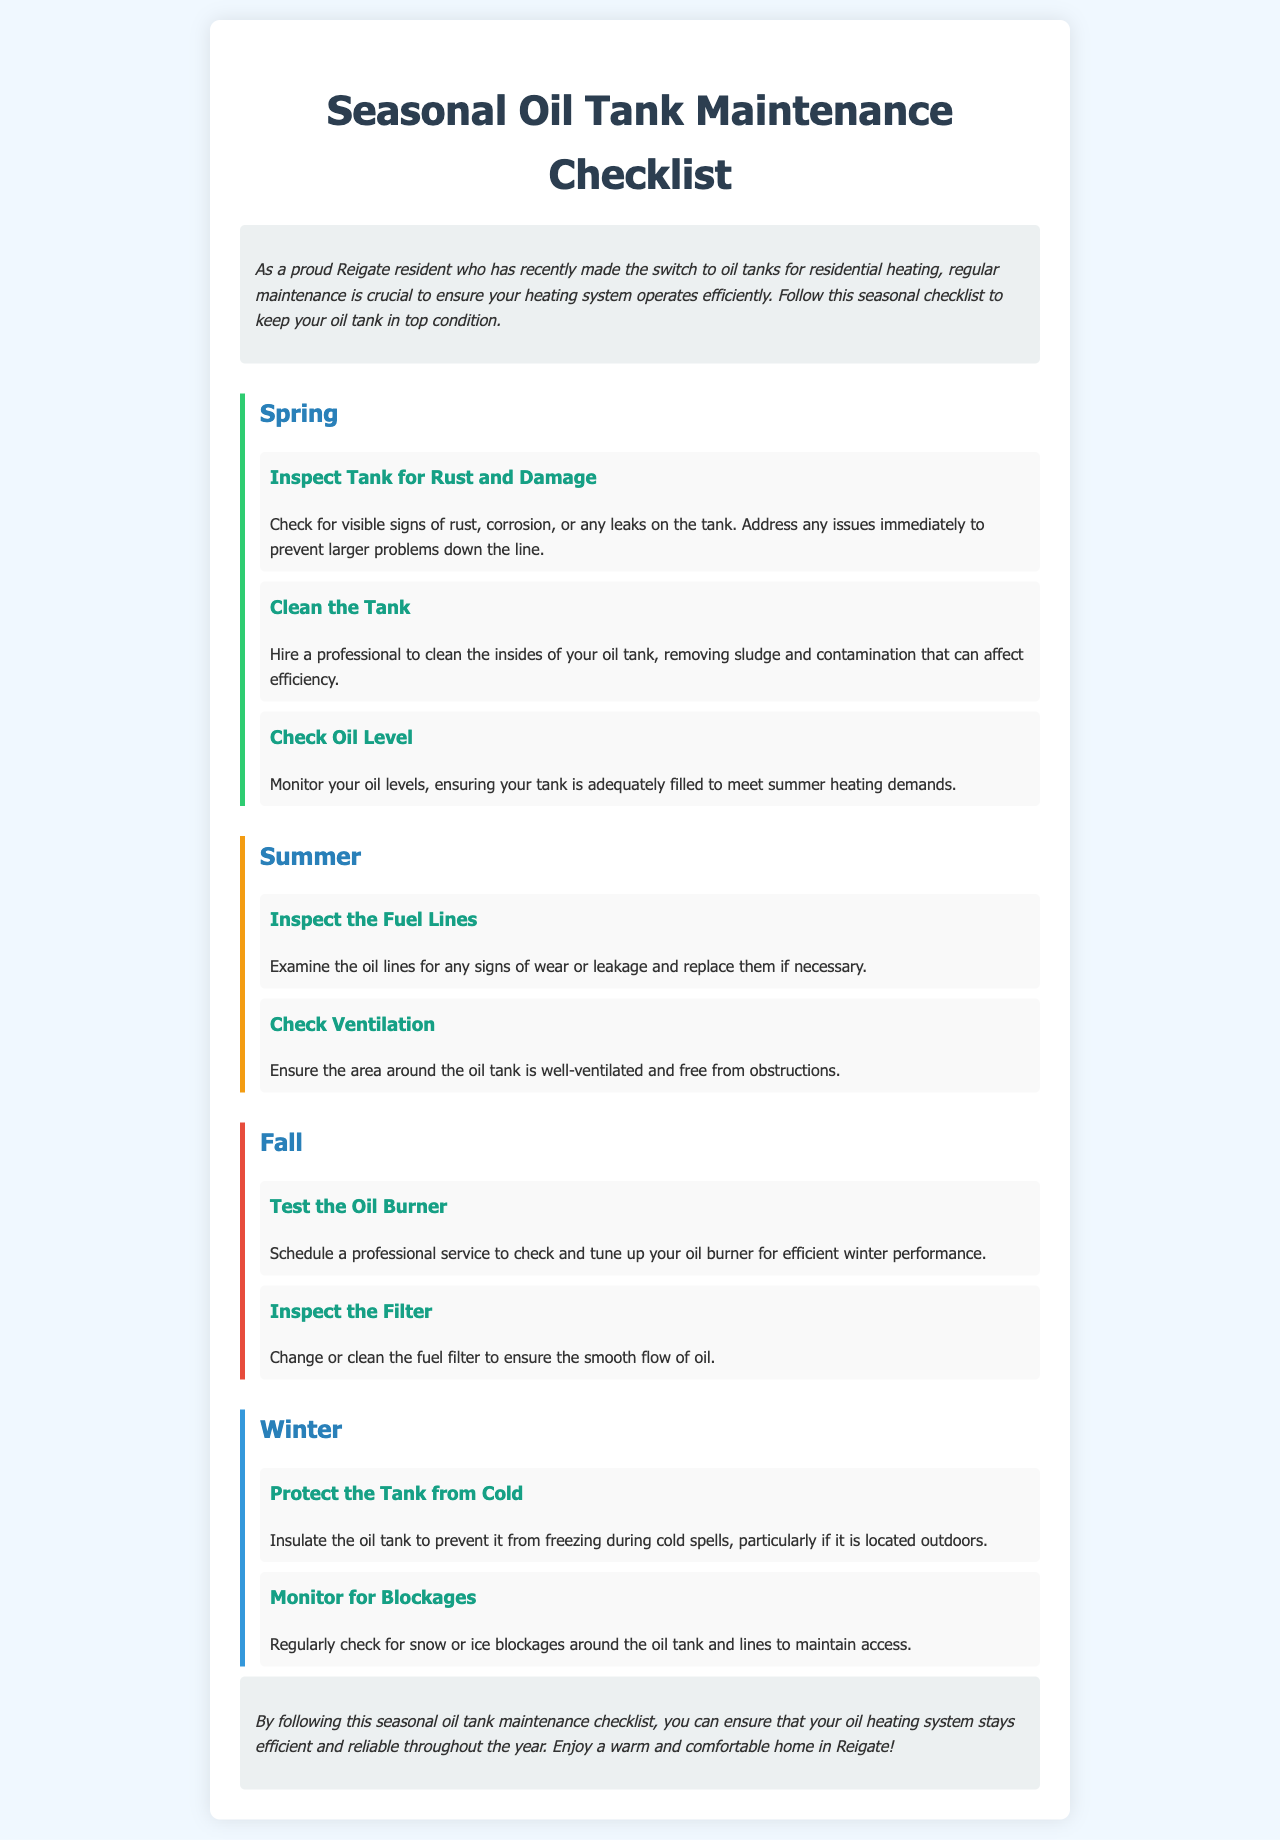What should be inspected in the spring? The document states to inspect the tank for rust and damage.
Answer: Rust and damage How many tasks are listed for the summer? The summer section contains two tasks.
Answer: Two What is recommended to do with the oil burner in the fall? The document advises to schedule a professional service to check and tune up the oil burner.
Answer: Professional service What is one task mentioned for winter? One task listed for winter is to insulate the oil tank to prevent it from freezing.
Answer: Insulate the oil tank What color is used for the spring section border? The spring section border is colored green, represented by the code #2ecc71.
Answer: Green 